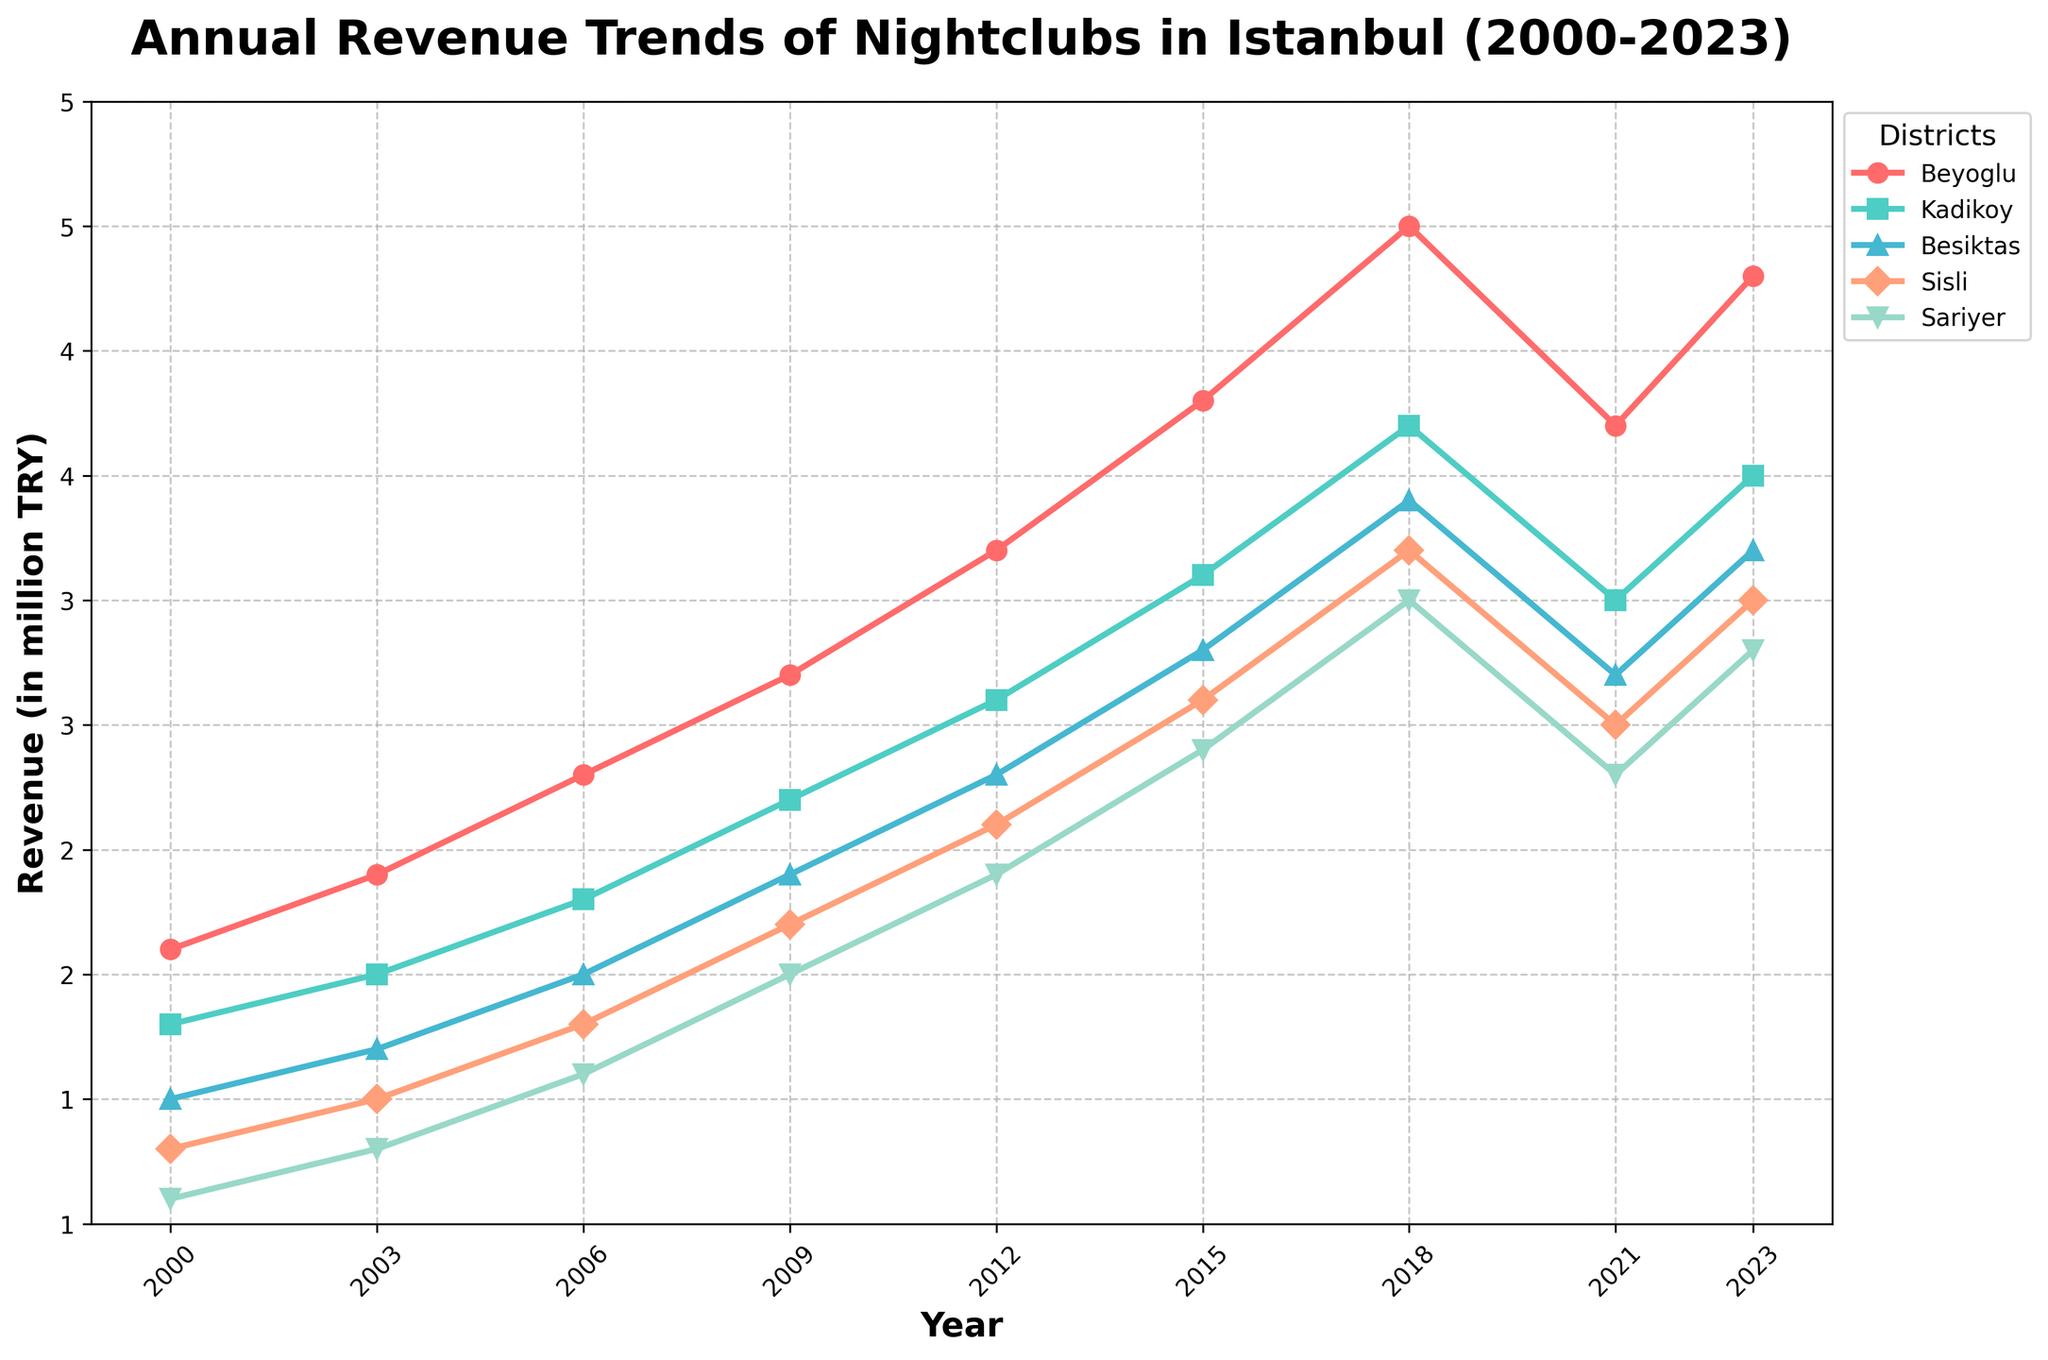What is the overall trend of revenue for nightclubs in Beyoglu from 2000 to 2023? To determine the overall trend for Beyoglu, observe the line associated with it. From 2000 to 2023, the revenue increases steadily, peaking in 2018 before a drop in 2021, and then rises again in 2023.
Answer: Upward trend with a dip in 2021 Which district showed the highest revenue in 2018? Check the value for each district in 2018. Beyoglu has the highest revenue in 2018 at 5,000,000 TRY.
Answer: Beyoglu How did the revenue of Kadikoy change from 2021 to 2023? For Kadikoy, compare the revenue in 2021 (3,500,000 TRY) to 2023 (4,000,000 TRY). The revenue increased.
Answer: Increased Which district had the lowest revenue in 2000, and what was the value? To determine this, compare the revenue for all districts in 2000. Sariyer had the lowest revenue at 1,100,000 TRY.
Answer: Sariyer, 1,100,000 TRY What year did Besiktas' revenue first reach or exceed 3,000,000 TRY? Inspect Besiktas' revenue across the years. In 2015, Besiktas' revenue first reached 3,300,000 TRY.
Answer: 2015 Compare the revenue trend of Sisli and Sariyer since 2000. Which district has shown a more significant increase by 2023? Look at the revenue of Sisli and Sariyer from 2000 to 2023. Sisli increased from 1,300,000 to 3,500,000 TRY, and Sariyer from 1,100,000 to 3,300,000 TRY. Sisli has shown a more significant increase.
Answer: Sisli What is the difference in revenue between the highest and lowest-grossing districts in 2023? For 2023, Beyoglu has the highest revenue (4,800,000 TRY), and Sariyer has the lowest (3,300,000 TRY). The difference is 4,800,000 - 3,300,000 = 1,500,000 TRY.
Answer: 1,500,000 TRY What was the average revenue for nightclubs in all districts in 2009? Sum the revenues of all districts in 2009 (3,200,000 + 2,700,000 + 2,400,000 + 2,200,000 + 2,000,000) and divide by the number of districts (5). The average is (3,200,000 + 2,700,000 + 2,400,000 + 2,200,000 + 2,000,000) / 5 = 2,500,000 TRY.
Answer: 2,500,000 TRY 